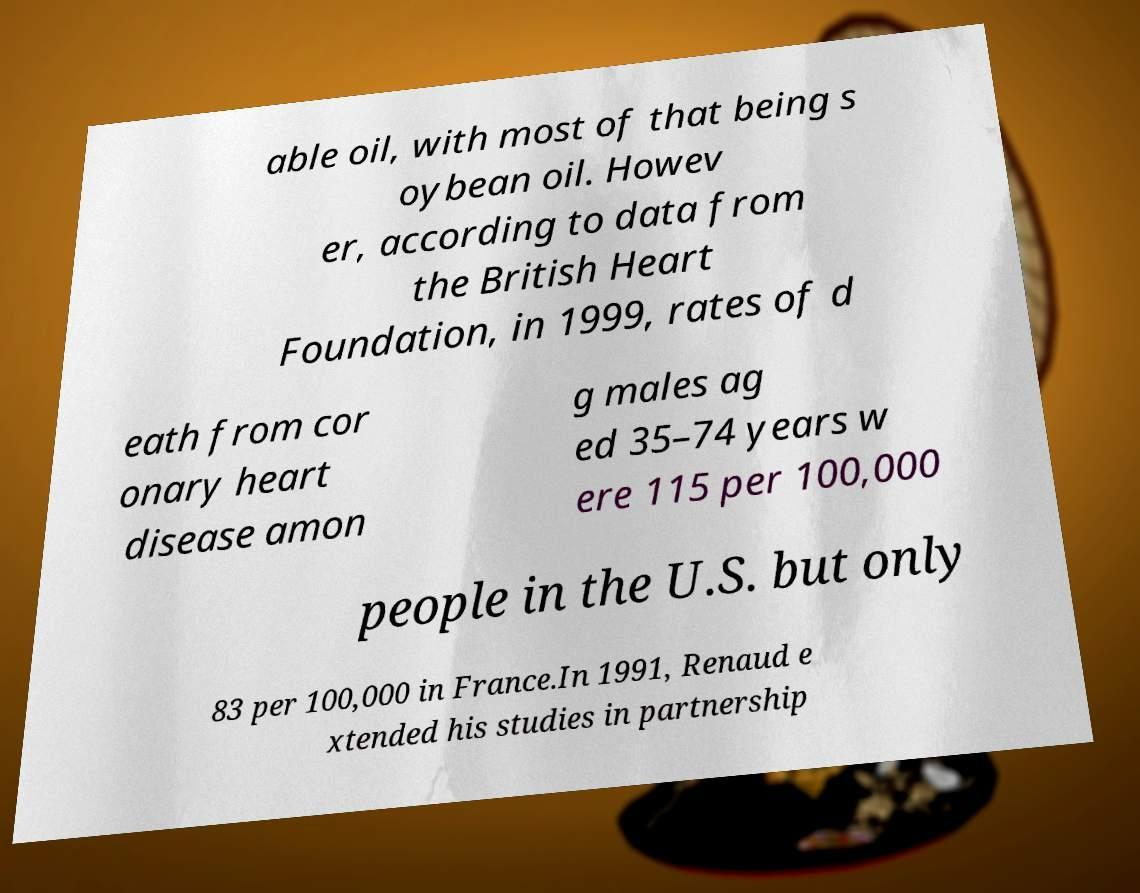Please read and relay the text visible in this image. What does it say? able oil, with most of that being s oybean oil. Howev er, according to data from the British Heart Foundation, in 1999, rates of d eath from cor onary heart disease amon g males ag ed 35–74 years w ere 115 per 100,000 people in the U.S. but only 83 per 100,000 in France.In 1991, Renaud e xtended his studies in partnership 